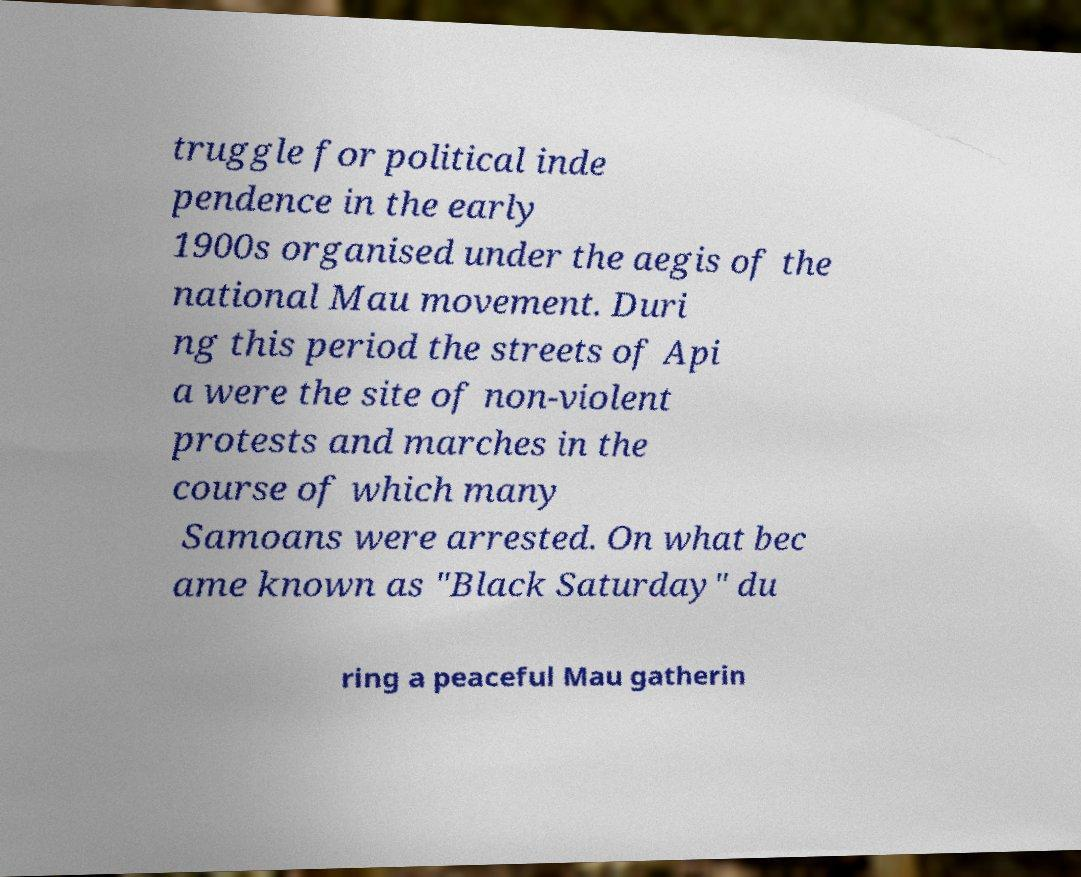Please read and relay the text visible in this image. What does it say? truggle for political inde pendence in the early 1900s organised under the aegis of the national Mau movement. Duri ng this period the streets of Api a were the site of non-violent protests and marches in the course of which many Samoans were arrested. On what bec ame known as "Black Saturday" du ring a peaceful Mau gatherin 